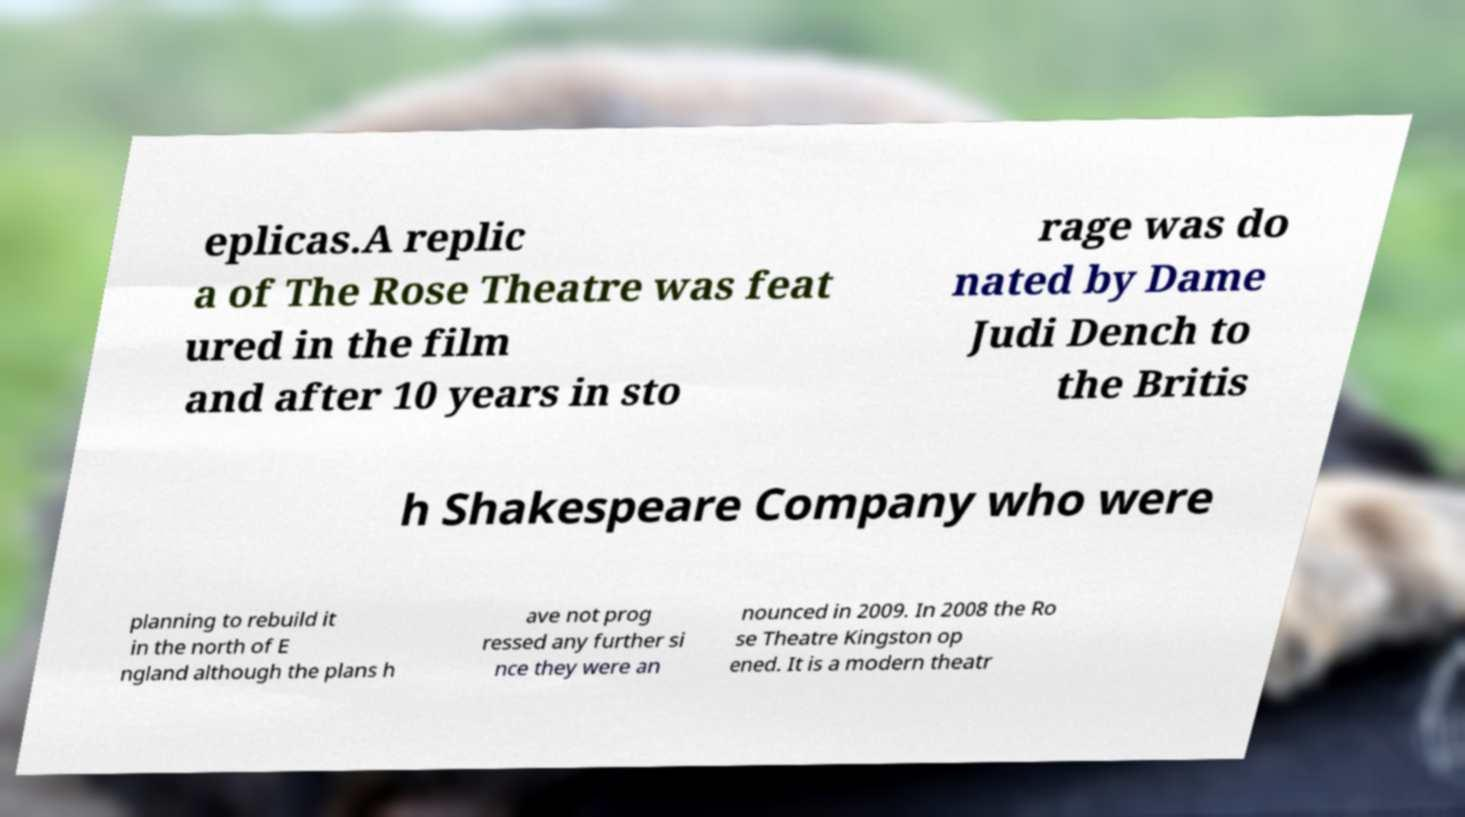I need the written content from this picture converted into text. Can you do that? eplicas.A replic a of The Rose Theatre was feat ured in the film and after 10 years in sto rage was do nated by Dame Judi Dench to the Britis h Shakespeare Company who were planning to rebuild it in the north of E ngland although the plans h ave not prog ressed any further si nce they were an nounced in 2009. In 2008 the Ro se Theatre Kingston op ened. It is a modern theatr 